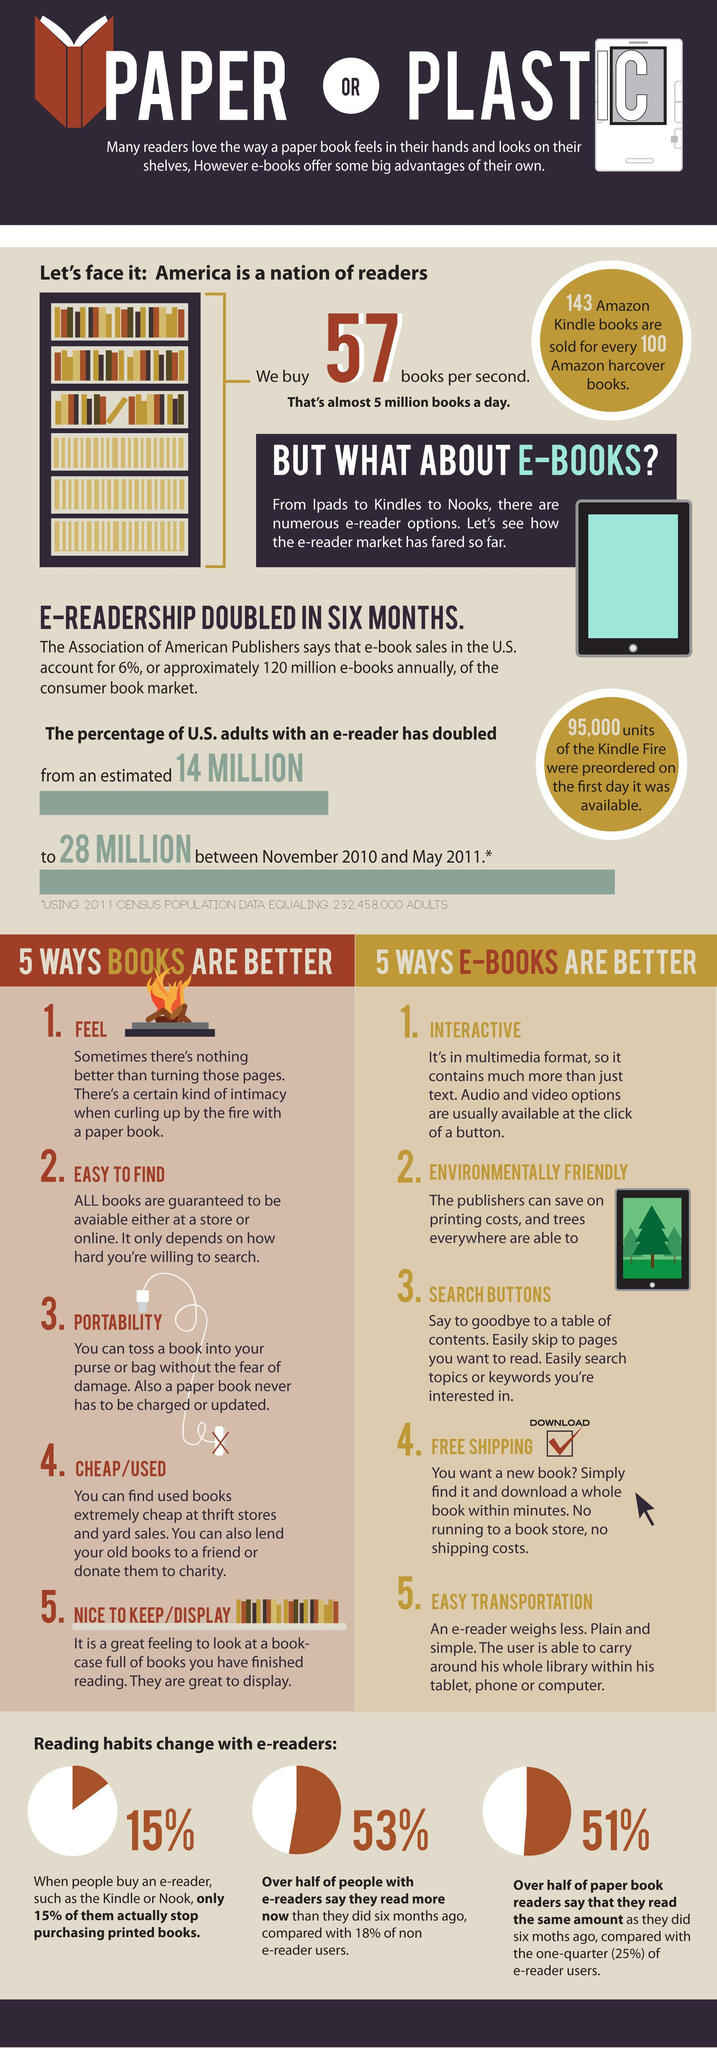List a handful of essential elements in this visual. A recent survey found that 53% of e-readers in the U.S. claim to have read more books in the past six months than they did previously. According to a survey, 51% of paper book readers in the U.S. claim to have read the same amount as they did six months ago. 